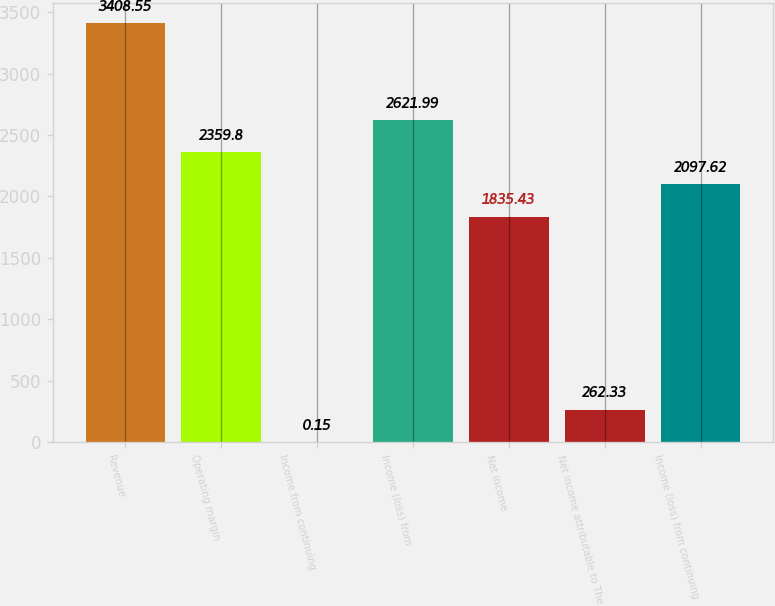<chart> <loc_0><loc_0><loc_500><loc_500><bar_chart><fcel>Revenue<fcel>Operating margin<fcel>Income from continuing<fcel>Income (loss) from<fcel>Net income<fcel>Net income attributable to The<fcel>Income (loss) from continuing<nl><fcel>3408.55<fcel>2359.8<fcel>0.15<fcel>2621.99<fcel>1835.43<fcel>262.33<fcel>2097.62<nl></chart> 